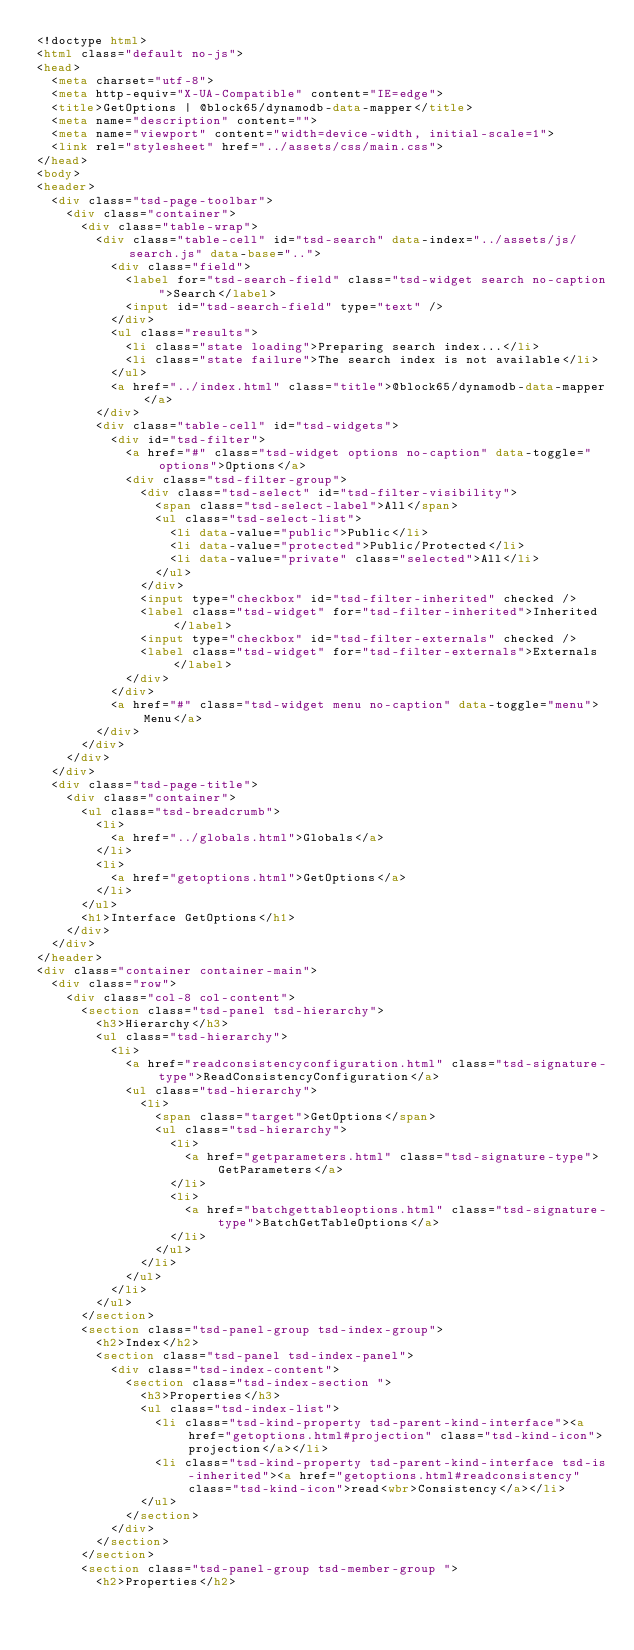<code> <loc_0><loc_0><loc_500><loc_500><_HTML_><!doctype html>
<html class="default no-js">
<head>
	<meta charset="utf-8">
	<meta http-equiv="X-UA-Compatible" content="IE=edge">
	<title>GetOptions | @block65/dynamodb-data-mapper</title>
	<meta name="description" content="">
	<meta name="viewport" content="width=device-width, initial-scale=1">
	<link rel="stylesheet" href="../assets/css/main.css">
</head>
<body>
<header>
	<div class="tsd-page-toolbar">
		<div class="container">
			<div class="table-wrap">
				<div class="table-cell" id="tsd-search" data-index="../assets/js/search.js" data-base="..">
					<div class="field">
						<label for="tsd-search-field" class="tsd-widget search no-caption">Search</label>
						<input id="tsd-search-field" type="text" />
					</div>
					<ul class="results">
						<li class="state loading">Preparing search index...</li>
						<li class="state failure">The search index is not available</li>
					</ul>
					<a href="../index.html" class="title">@block65/dynamodb-data-mapper</a>
				</div>
				<div class="table-cell" id="tsd-widgets">
					<div id="tsd-filter">
						<a href="#" class="tsd-widget options no-caption" data-toggle="options">Options</a>
						<div class="tsd-filter-group">
							<div class="tsd-select" id="tsd-filter-visibility">
								<span class="tsd-select-label">All</span>
								<ul class="tsd-select-list">
									<li data-value="public">Public</li>
									<li data-value="protected">Public/Protected</li>
									<li data-value="private" class="selected">All</li>
								</ul>
							</div>
							<input type="checkbox" id="tsd-filter-inherited" checked />
							<label class="tsd-widget" for="tsd-filter-inherited">Inherited</label>
							<input type="checkbox" id="tsd-filter-externals" checked />
							<label class="tsd-widget" for="tsd-filter-externals">Externals</label>
						</div>
					</div>
					<a href="#" class="tsd-widget menu no-caption" data-toggle="menu">Menu</a>
				</div>
			</div>
		</div>
	</div>
	<div class="tsd-page-title">
		<div class="container">
			<ul class="tsd-breadcrumb">
				<li>
					<a href="../globals.html">Globals</a>
				</li>
				<li>
					<a href="getoptions.html">GetOptions</a>
				</li>
			</ul>
			<h1>Interface GetOptions</h1>
		</div>
	</div>
</header>
<div class="container container-main">
	<div class="row">
		<div class="col-8 col-content">
			<section class="tsd-panel tsd-hierarchy">
				<h3>Hierarchy</h3>
				<ul class="tsd-hierarchy">
					<li>
						<a href="readconsistencyconfiguration.html" class="tsd-signature-type">ReadConsistencyConfiguration</a>
						<ul class="tsd-hierarchy">
							<li>
								<span class="target">GetOptions</span>
								<ul class="tsd-hierarchy">
									<li>
										<a href="getparameters.html" class="tsd-signature-type">GetParameters</a>
									</li>
									<li>
										<a href="batchgettableoptions.html" class="tsd-signature-type">BatchGetTableOptions</a>
									</li>
								</ul>
							</li>
						</ul>
					</li>
				</ul>
			</section>
			<section class="tsd-panel-group tsd-index-group">
				<h2>Index</h2>
				<section class="tsd-panel tsd-index-panel">
					<div class="tsd-index-content">
						<section class="tsd-index-section ">
							<h3>Properties</h3>
							<ul class="tsd-index-list">
								<li class="tsd-kind-property tsd-parent-kind-interface"><a href="getoptions.html#projection" class="tsd-kind-icon">projection</a></li>
								<li class="tsd-kind-property tsd-parent-kind-interface tsd-is-inherited"><a href="getoptions.html#readconsistency" class="tsd-kind-icon">read<wbr>Consistency</a></li>
							</ul>
						</section>
					</div>
				</section>
			</section>
			<section class="tsd-panel-group tsd-member-group ">
				<h2>Properties</h2></code> 